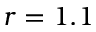Convert formula to latex. <formula><loc_0><loc_0><loc_500><loc_500>r = 1 . 1</formula> 